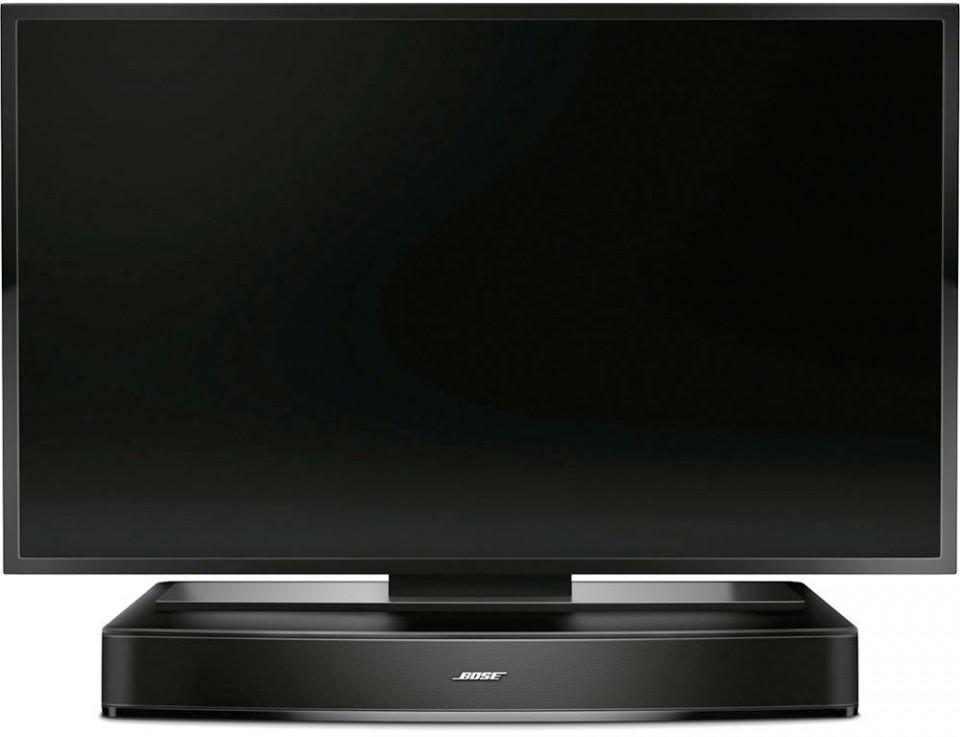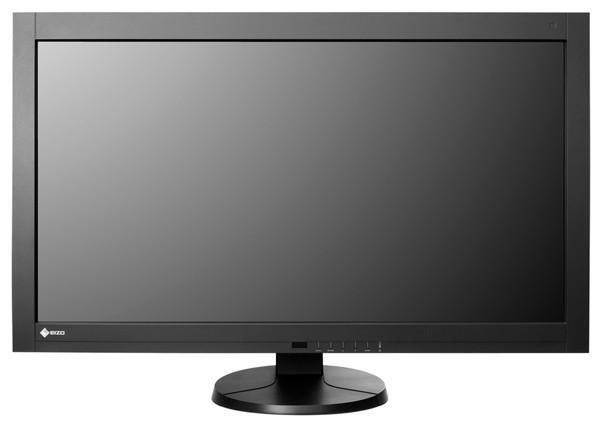The first image is the image on the left, the second image is the image on the right. Given the left and right images, does the statement "Each image contains a rectangular gray-black screen that is displayed head-on instead of at an angle." hold true? Answer yes or no. Yes. The first image is the image on the left, the second image is the image on the right. Considering the images on both sides, is "One picture shows a TV above a piece of furniture." valid? Answer yes or no. No. 